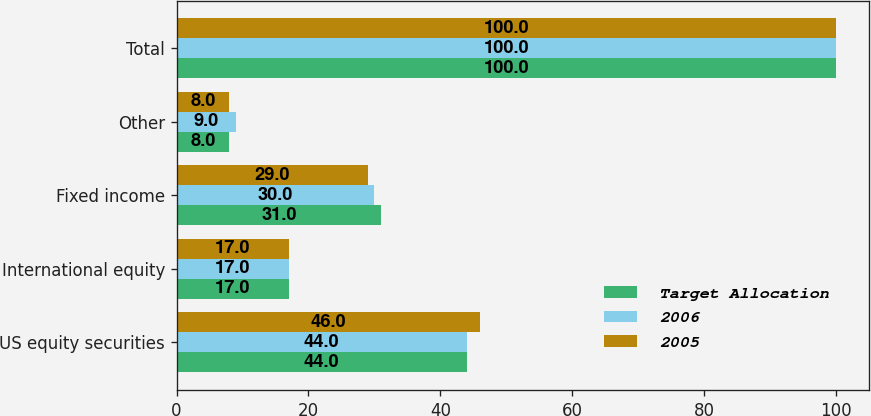Convert chart to OTSL. <chart><loc_0><loc_0><loc_500><loc_500><stacked_bar_chart><ecel><fcel>US equity securities<fcel>International equity<fcel>Fixed income<fcel>Other<fcel>Total<nl><fcel>Target Allocation<fcel>44<fcel>17<fcel>31<fcel>8<fcel>100<nl><fcel>2006<fcel>44<fcel>17<fcel>30<fcel>9<fcel>100<nl><fcel>2005<fcel>46<fcel>17<fcel>29<fcel>8<fcel>100<nl></chart> 